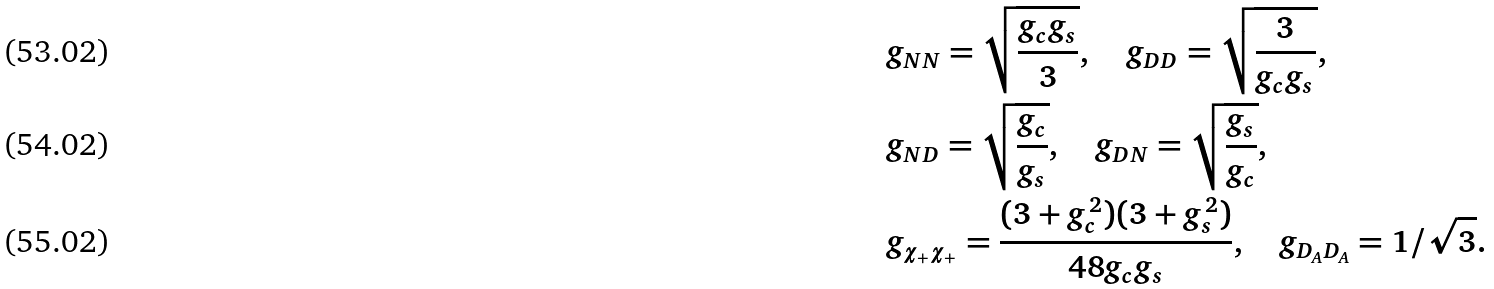Convert formula to latex. <formula><loc_0><loc_0><loc_500><loc_500>& g _ { N N } = \sqrt { \frac { g _ { c } g _ { s } } { 3 } } , \quad g _ { D D } = \sqrt { \frac { 3 } { g _ { c } g _ { s } } } , \\ & g _ { N D } = \sqrt { \frac { g _ { c } } { g _ { s } } } , \quad g _ { D N } = \sqrt { \frac { g _ { s } } { g _ { c } } } , \\ & g _ { \chi _ { + } \chi _ { + } } = \frac { ( 3 + g _ { c } ^ { 2 } ) ( 3 + g _ { s } ^ { 2 } ) } { 4 8 g _ { c } g _ { s } } , \quad g _ { D _ { A } D _ { A } } = 1 / \sqrt { 3 } .</formula> 